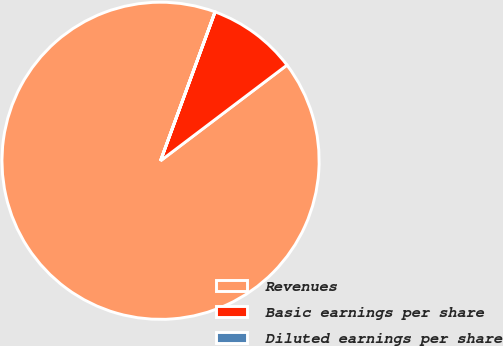Convert chart. <chart><loc_0><loc_0><loc_500><loc_500><pie_chart><fcel>Revenues<fcel>Basic earnings per share<fcel>Diluted earnings per share<nl><fcel>90.9%<fcel>9.1%<fcel>0.01%<nl></chart> 